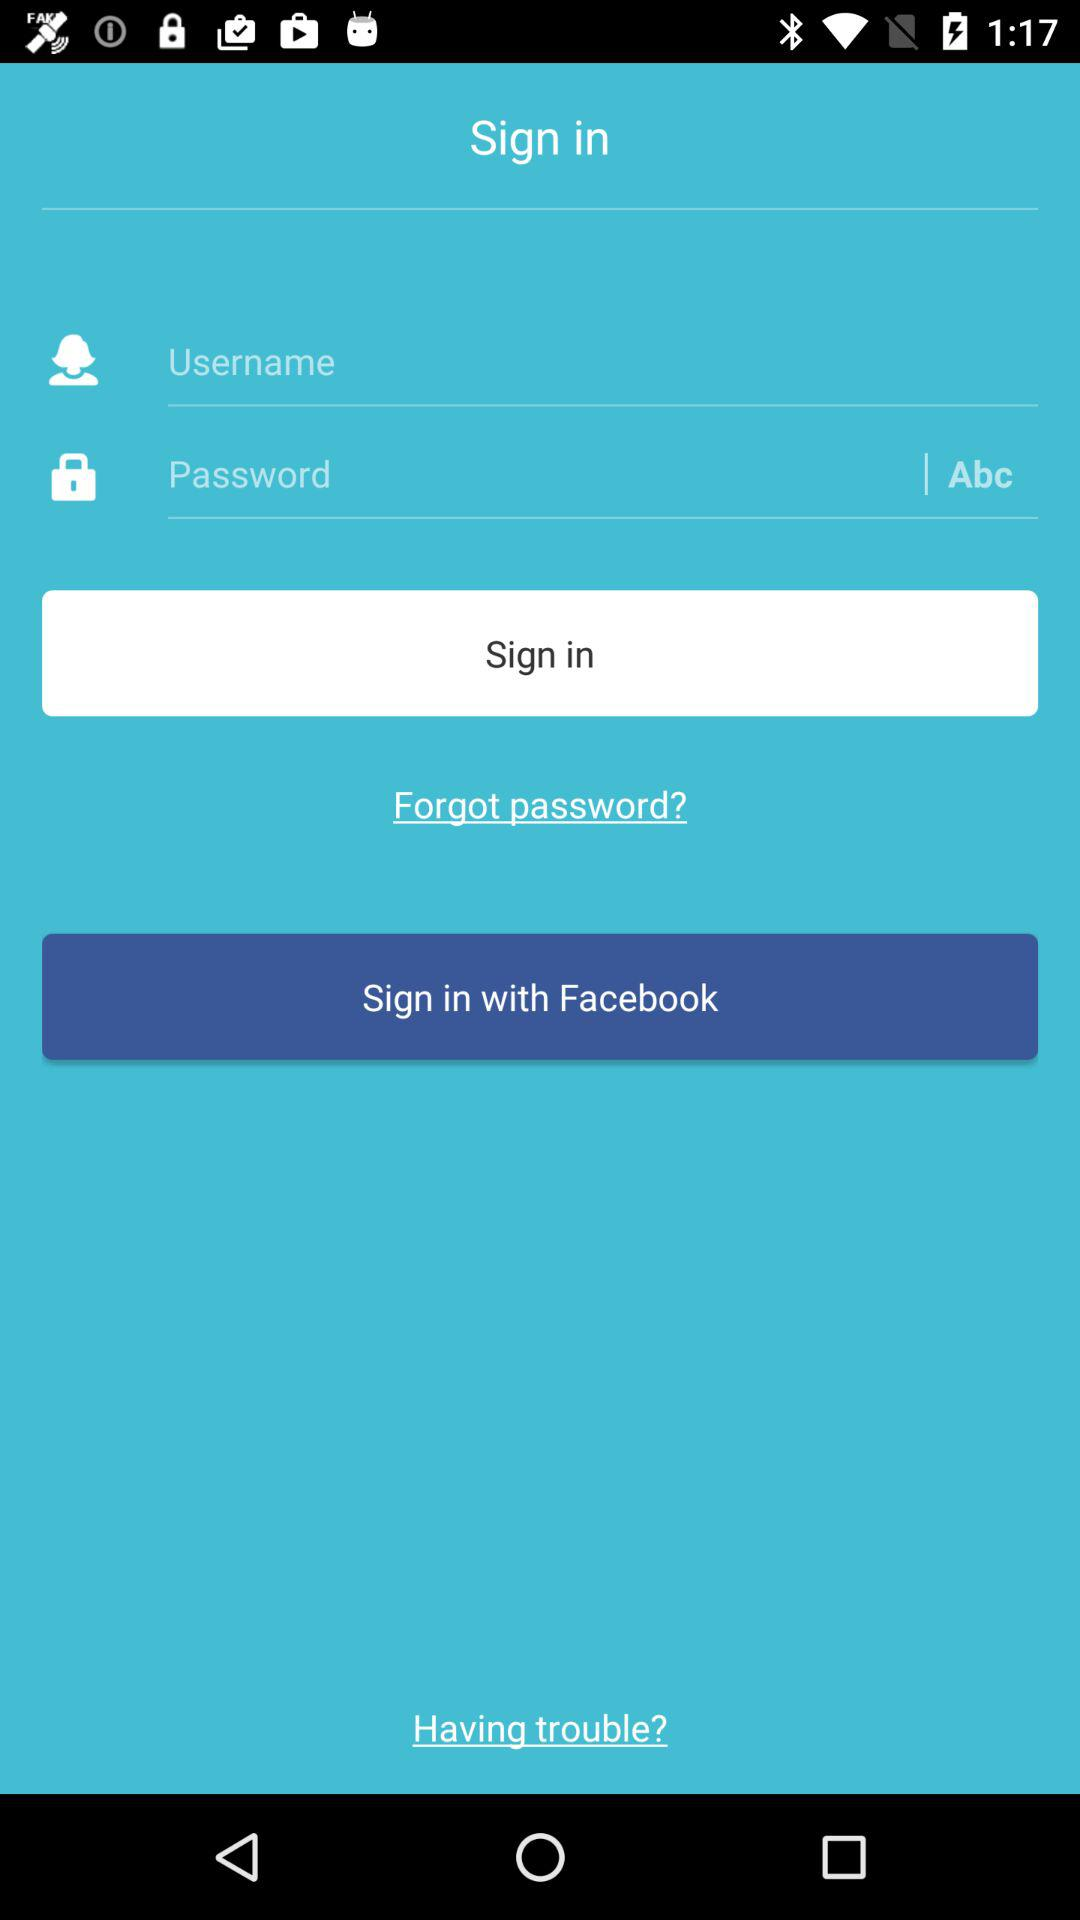What application can be used to sign in? The application that can be used to sign in is "Facebook". 